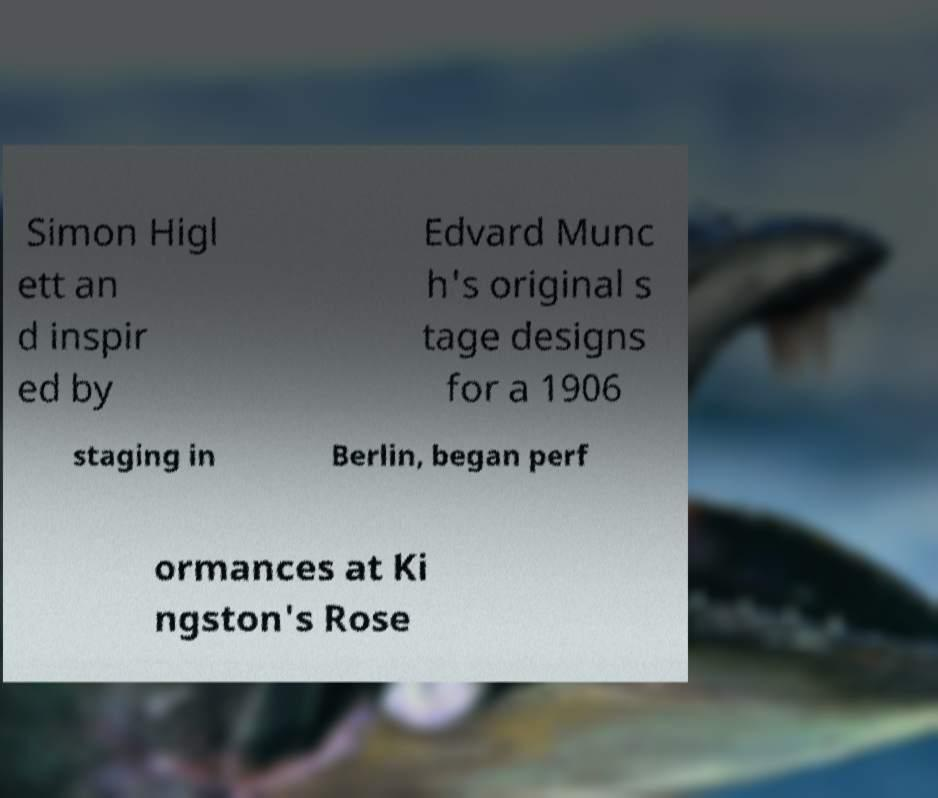What messages or text are displayed in this image? I need them in a readable, typed format. Simon Higl ett an d inspir ed by Edvard Munc h's original s tage designs for a 1906 staging in Berlin, began perf ormances at Ki ngston's Rose 